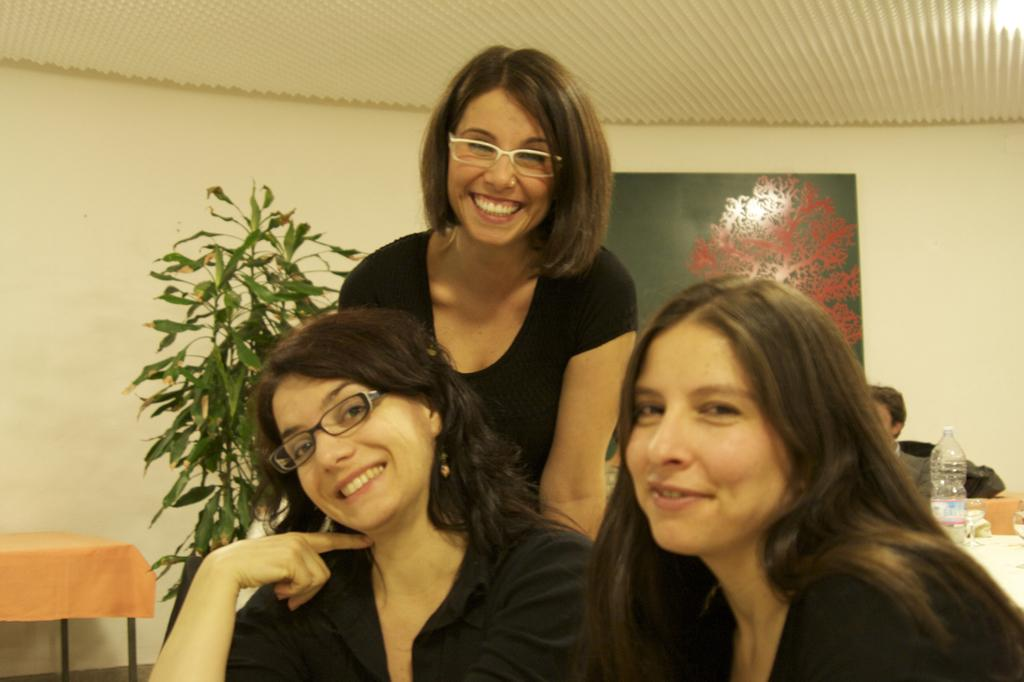How many individuals are present in the image? There are three people in the image. What can be seen to the right of the people? There is a plant to the right of the people. What is located in the background of the image? There is a board attached to a wall in the background of the image. What type of money is being exchanged between the people in the image? There is no indication of money or any exchange taking place in the image. Can you tell me how many quills are visible in the image? There are no quills present in the image. 